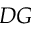<formula> <loc_0><loc_0><loc_500><loc_500>D G</formula> 